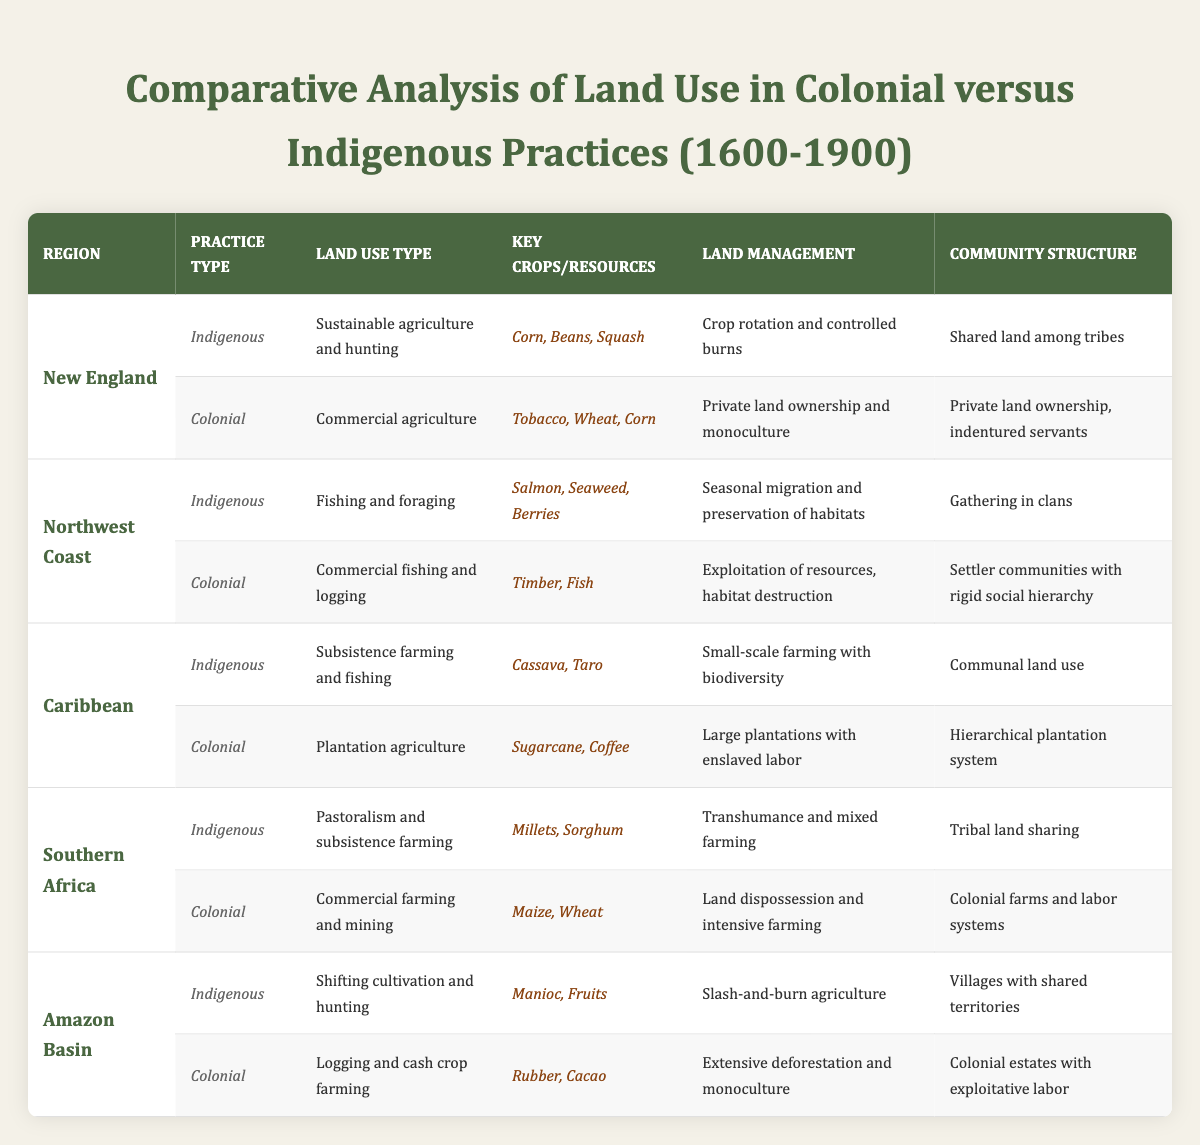What is the land use type for indigenous practices in New England? The table lists "Sustainable agriculture and hunting" as the land use type for indigenous practices in New England. This information is directly retrieved from the relevant row in the table.
Answer: Sustainable agriculture and hunting What key crops were used in colonial practices in the Caribbean? According to the table, the key crops for colonial practices in the Caribbean are "Sugarcane" and "Coffee." This is found in the corresponding column for colonial practices under the Caribbean region.
Answer: Sugarcane, Coffee Did indigenous practices in Southern Africa involve land dispossession? The table indicates that indigenous practices in Southern Africa involved "Tribal land sharing," while colonial practices included "Land dispossession." Thus, indigenous practices did not involve land dispossession as per the table findings.
Answer: No How many different land use types are mentioned for both indigenous and colonial practices in the Amazon Basin? The table specifies one land use type for indigenous practices ("Shifting cultivation and hunting") and one for colonial practices ("Logging and cash crop farming") in the Amazon Basin. Therefore, the total is 1 + 1 = 2 distinct land use types.
Answer: 2 Which region had the highest diversity of crops in indigenous practices, based on the table? By examining the key crops in indigenous practices across all regions, New England features three crops ("Corn, Beans, Squash"), while the Caribbean has two ("Cassava, Taro") and Southern Africa has two ("Millets, Sorghum"). Therefore, New England has the highest diversity with three distinctly stated crops.
Answer: New England What was the primary community structure among indigenous peoples in the Northwest Coast? The community structure for indigenous practices in the Northwest Coast, according to the table, is stated as "Gathering in clans." This is directly sourced from the regional entry for indigenous practices in that region.
Answer: Gathering in clans Compare the land management techniques of colonial practices in the Amazon Basin and Southern Africa. The table indicates that the colonial land management technique in the Amazon Basin is "Extensive deforestation and monoculture," while in Southern Africa it is "Land dispossession and intensive farming." Thus, the two techniques focus on different methods: deforestation in the Amazon Basin and land dispossession in Southern Africa.
Answer: Different methods What is the total number of unique key resources mentioned in the table for indigenous practices across all regions? Summarizing the unique key resources reveals: New England has "Corn, Beans, Squash," Northwest Coast has "Salmon, Seaweed, Berries," Caribbean has "Cassava, Taro," Southern Africa has "Millets, Sorghum," and Amazon Basin has "Manioc, Fruits." Listing these yields a total of 13 unique resources when duplicates are accounted individually. Thus, counting them provides a total of 13 unique key resources mentioned across all regions.
Answer: 13 